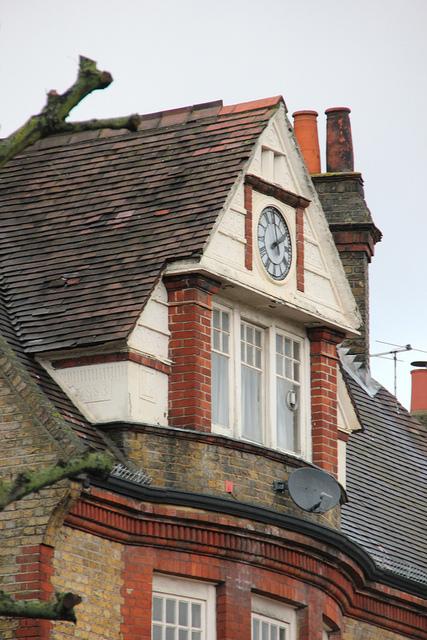What time is on the clock?
Answer briefly. 2:10. What is the building made of?
Be succinct. Brick. Would this building be easy to roof with new shingles?
Write a very short answer. No. What time does the clock say?
Quick response, please. 2:10. Is there a satellite dish?
Short answer required. Yes. 